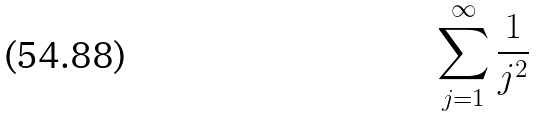<formula> <loc_0><loc_0><loc_500><loc_500>\sum _ { j = 1 } ^ { \infty } \frac { 1 } { j ^ { 2 } }</formula> 